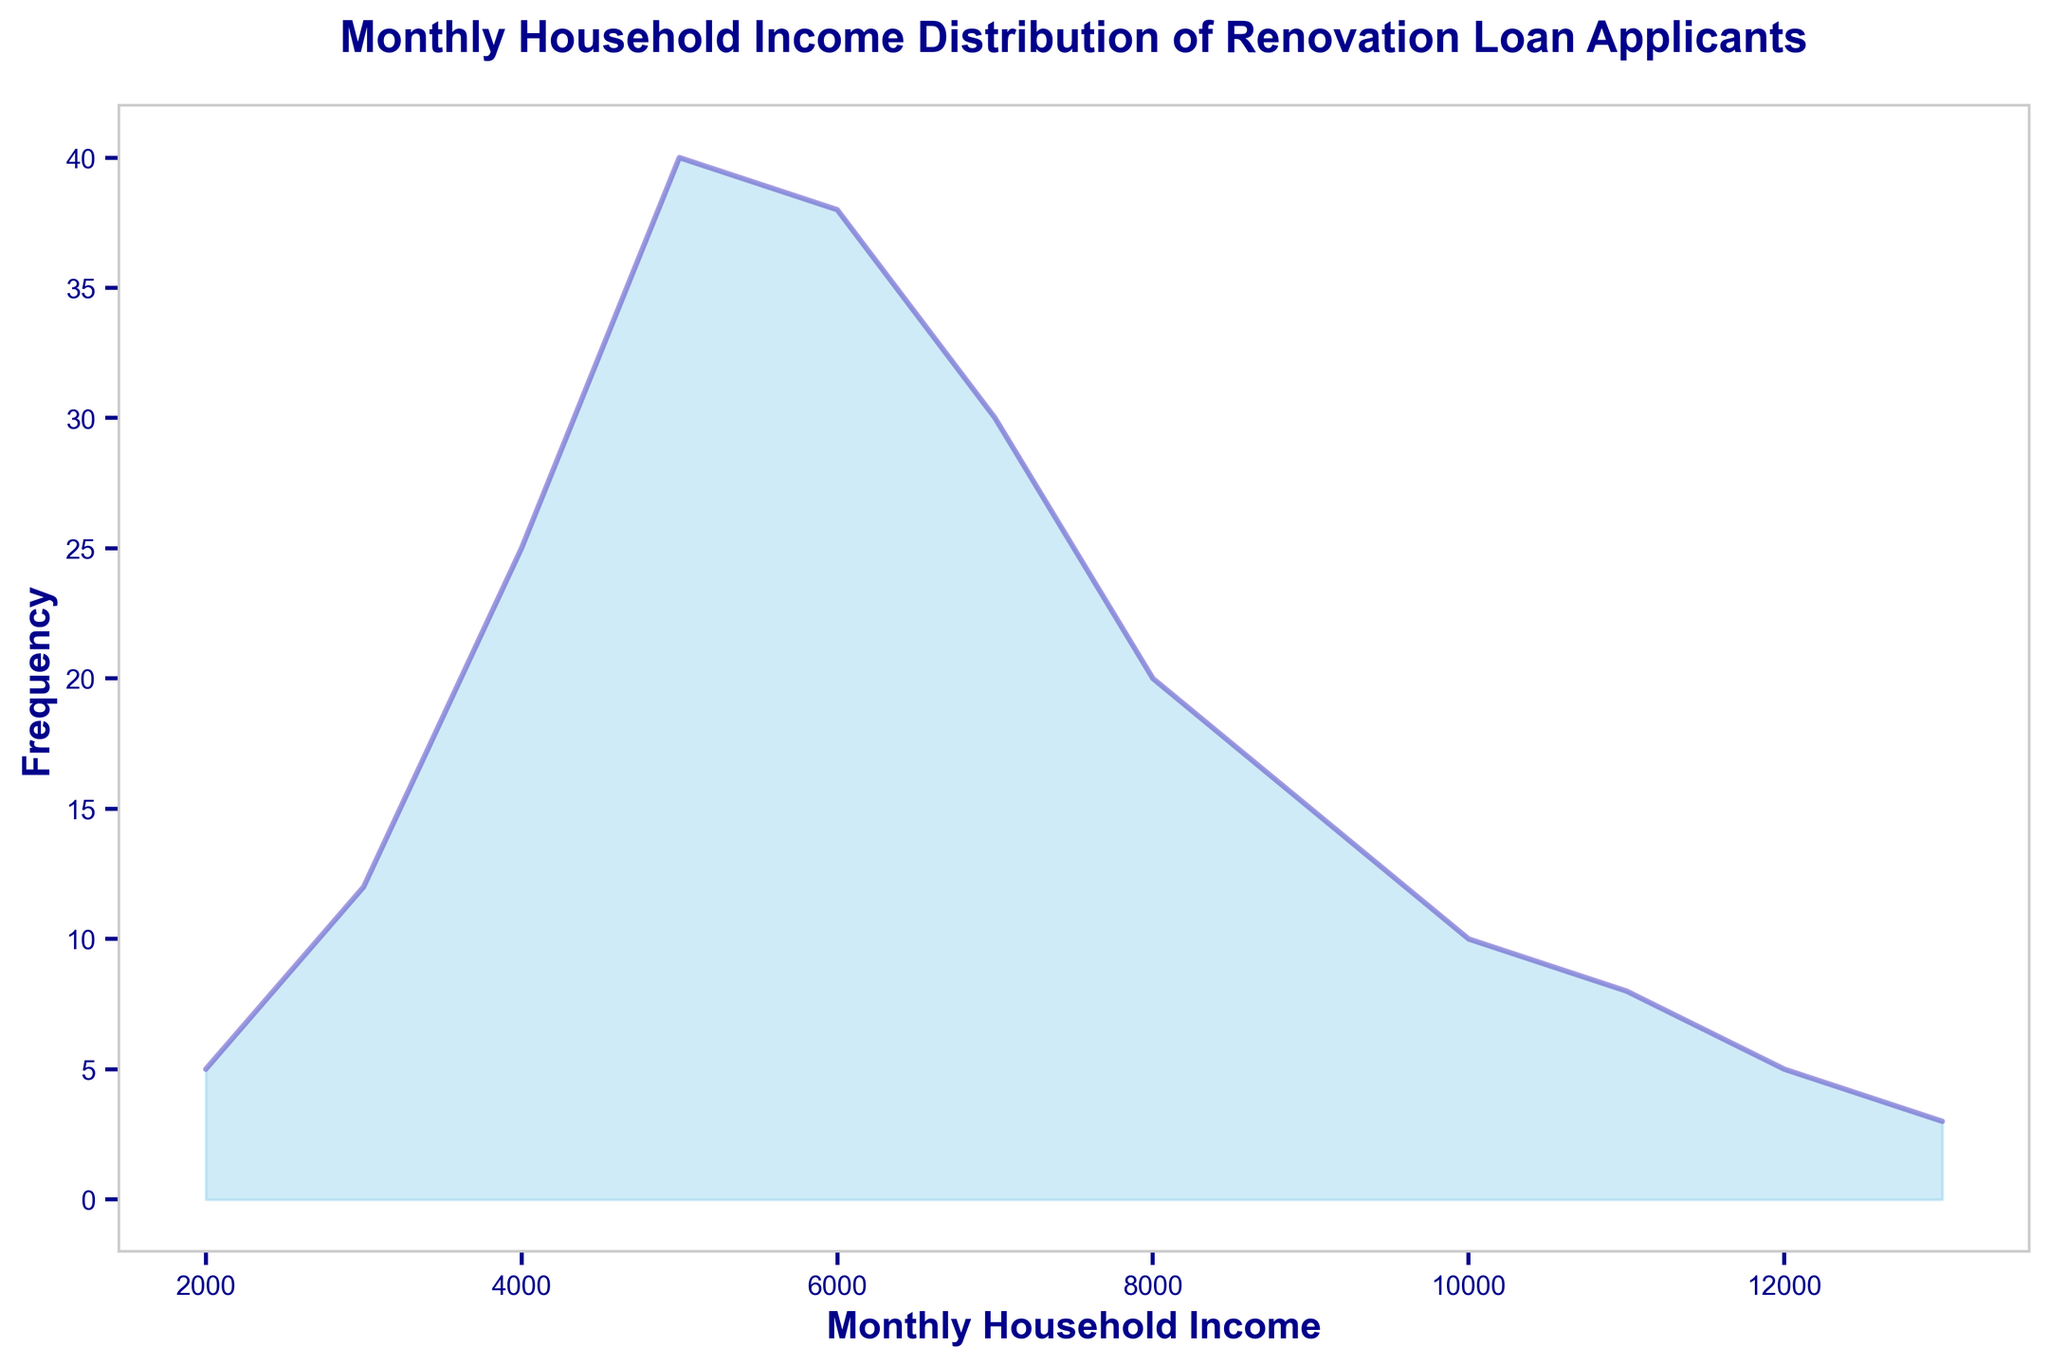What is the most common monthly household income among the renovation loan applicants? The peak of the area chart represents the most frequent income level. Looking at the chart, the highest frequency is at the income level of $5000.
Answer: $5000 Which income levels have the same frequency of applicants? By analyzing the height of the filled areas, we can see that the incomes of $11000 and $2000 have the same frequency of 5 and $10000 and $12000 have the same frequency of 5.
Answer: $11000 and $2000, $10000 and $12000 What is the combined frequency of applicants with a household income between $9000 and $11000 inclusive? Sum the frequencies for $9000 (15), $10000 (10), and $11000 (8), which gives 15 + 10 + 8 = 33 applicants
Answer: 33 Which income level has the second highest frequency of applicants? The highest frequency is at $5000 with 40 applicants. The second highest frequency is at $6000 with 38 applicants.
Answer: $6000 Is the number of applicants with an income of $7000 greater than that with an income of $9000? By comparing the chart heights, we see $7000 has 30 applicants and $9000 has 15 applicants. Therefore, 30 is greater than 15.
Answer: Yes At which income level does the frequency start to decrease after peaking? The frequency peaks at $5000 with 40 applicants and starts decreasing at $6000 with 38 applicants.
Answer: $6000 What is the color used to fill the area under the line in the chart? The description states the area under the line is filled with sky blue color in the chart.
Answer: Sky blue Which income level has the least number of applicants, and how many? The shortest filled area corresponds to the income level $13000 with 3 applicants.
Answer: $13000, 3 Between which two consecutive income levels is the largest drop in frequency? Compare the frequency drops between consecutive income levels; the largest drop is between $5000 (40) and $4000 (25) with a difference of 40 - 25 = 15.
Answer: $5000 and $4000 How many applicants have a household income above $8000? Sum the frequencies for income levels of $9000 (15), $10000 (10), $11000 (8), $12000 (5), and $13000 (3), which gives 15 + 10 + 8 + 5 + 3 = 41 applicants.
Answer: 41 